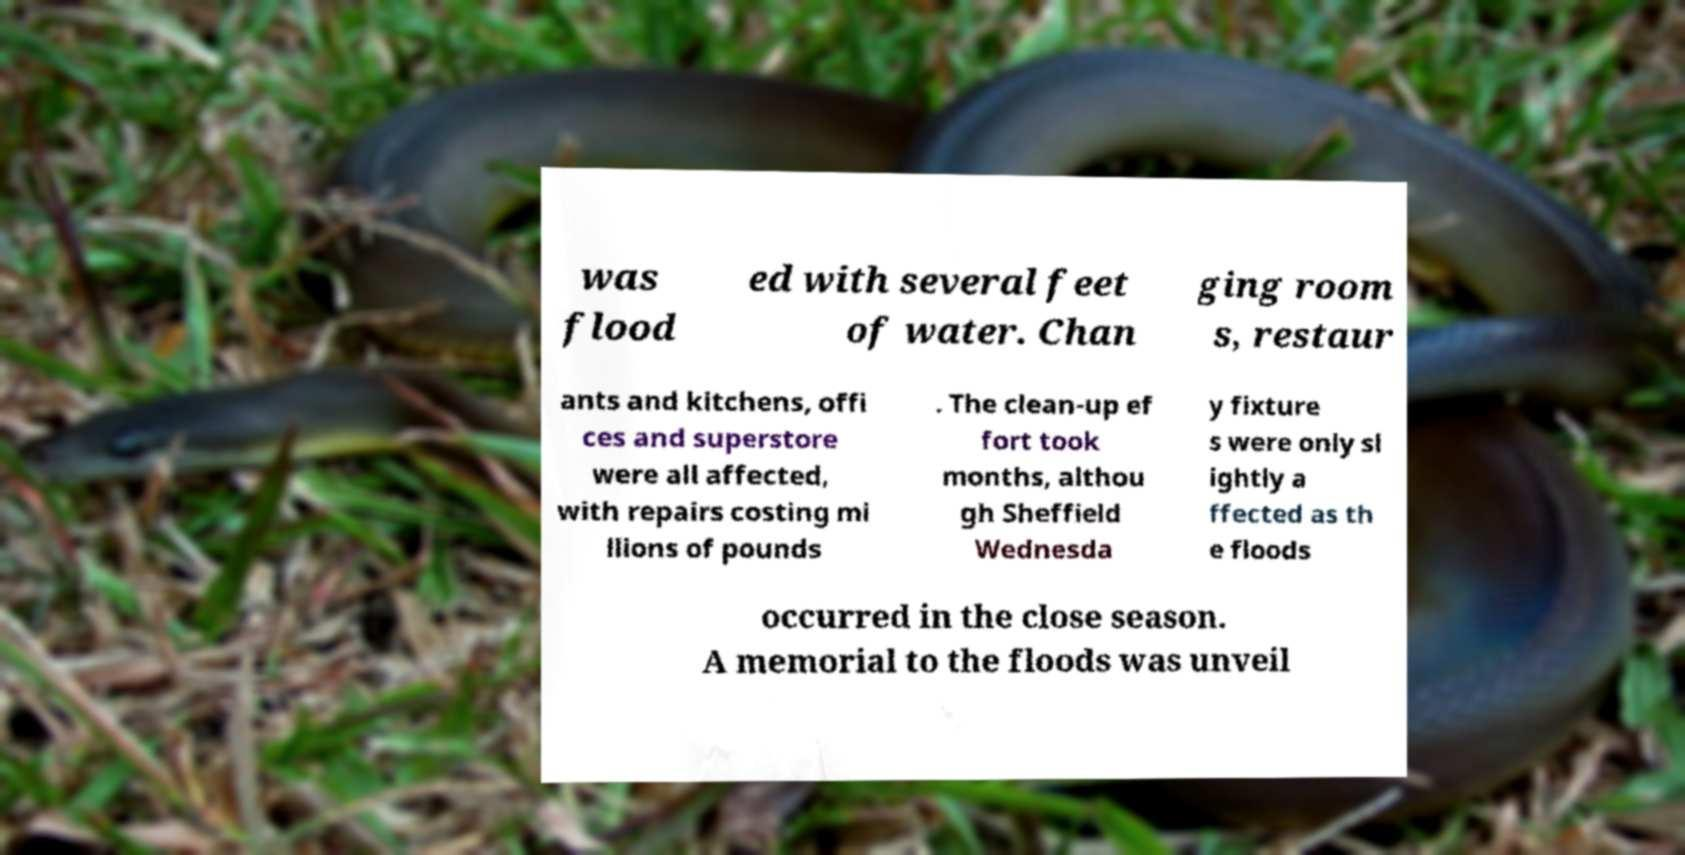Can you accurately transcribe the text from the provided image for me? was flood ed with several feet of water. Chan ging room s, restaur ants and kitchens, offi ces and superstore were all affected, with repairs costing mi llions of pounds . The clean-up ef fort took months, althou gh Sheffield Wednesda y fixture s were only sl ightly a ffected as th e floods occurred in the close season. A memorial to the floods was unveil 